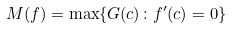<formula> <loc_0><loc_0><loc_500><loc_500>M ( f ) = \max \{ G ( c ) \colon f ^ { \prime } ( c ) = 0 \}</formula> 